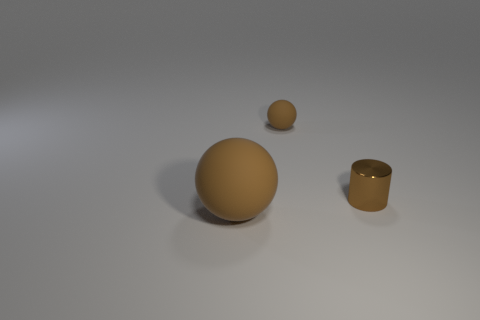There is a brown rubber thing right of the large brown matte thing; is its shape the same as the small brown metallic thing?
Offer a terse response. No. How many metal objects are either small brown cylinders or brown objects?
Ensure brevity in your answer.  1. Are there any tiny objects made of the same material as the cylinder?
Offer a very short reply. No. What is the material of the brown cylinder?
Your answer should be very brief. Metal. What shape is the small brown object right of the ball on the right side of the matte object left of the small rubber thing?
Provide a short and direct response. Cylinder. Is the number of tiny matte objects to the right of the big rubber object greater than the number of cylinders?
Give a very brief answer. No. Does the tiny brown shiny object have the same shape as the rubber object that is on the left side of the small brown rubber ball?
Offer a terse response. No. What is the shape of the other rubber object that is the same color as the large matte thing?
Provide a short and direct response. Sphere. There is a matte thing that is to the right of the large ball in front of the small brown metal cylinder; what number of big brown rubber balls are on the right side of it?
Your answer should be compact. 0. There is a matte ball that is the same size as the metal cylinder; what color is it?
Your response must be concise. Brown. 